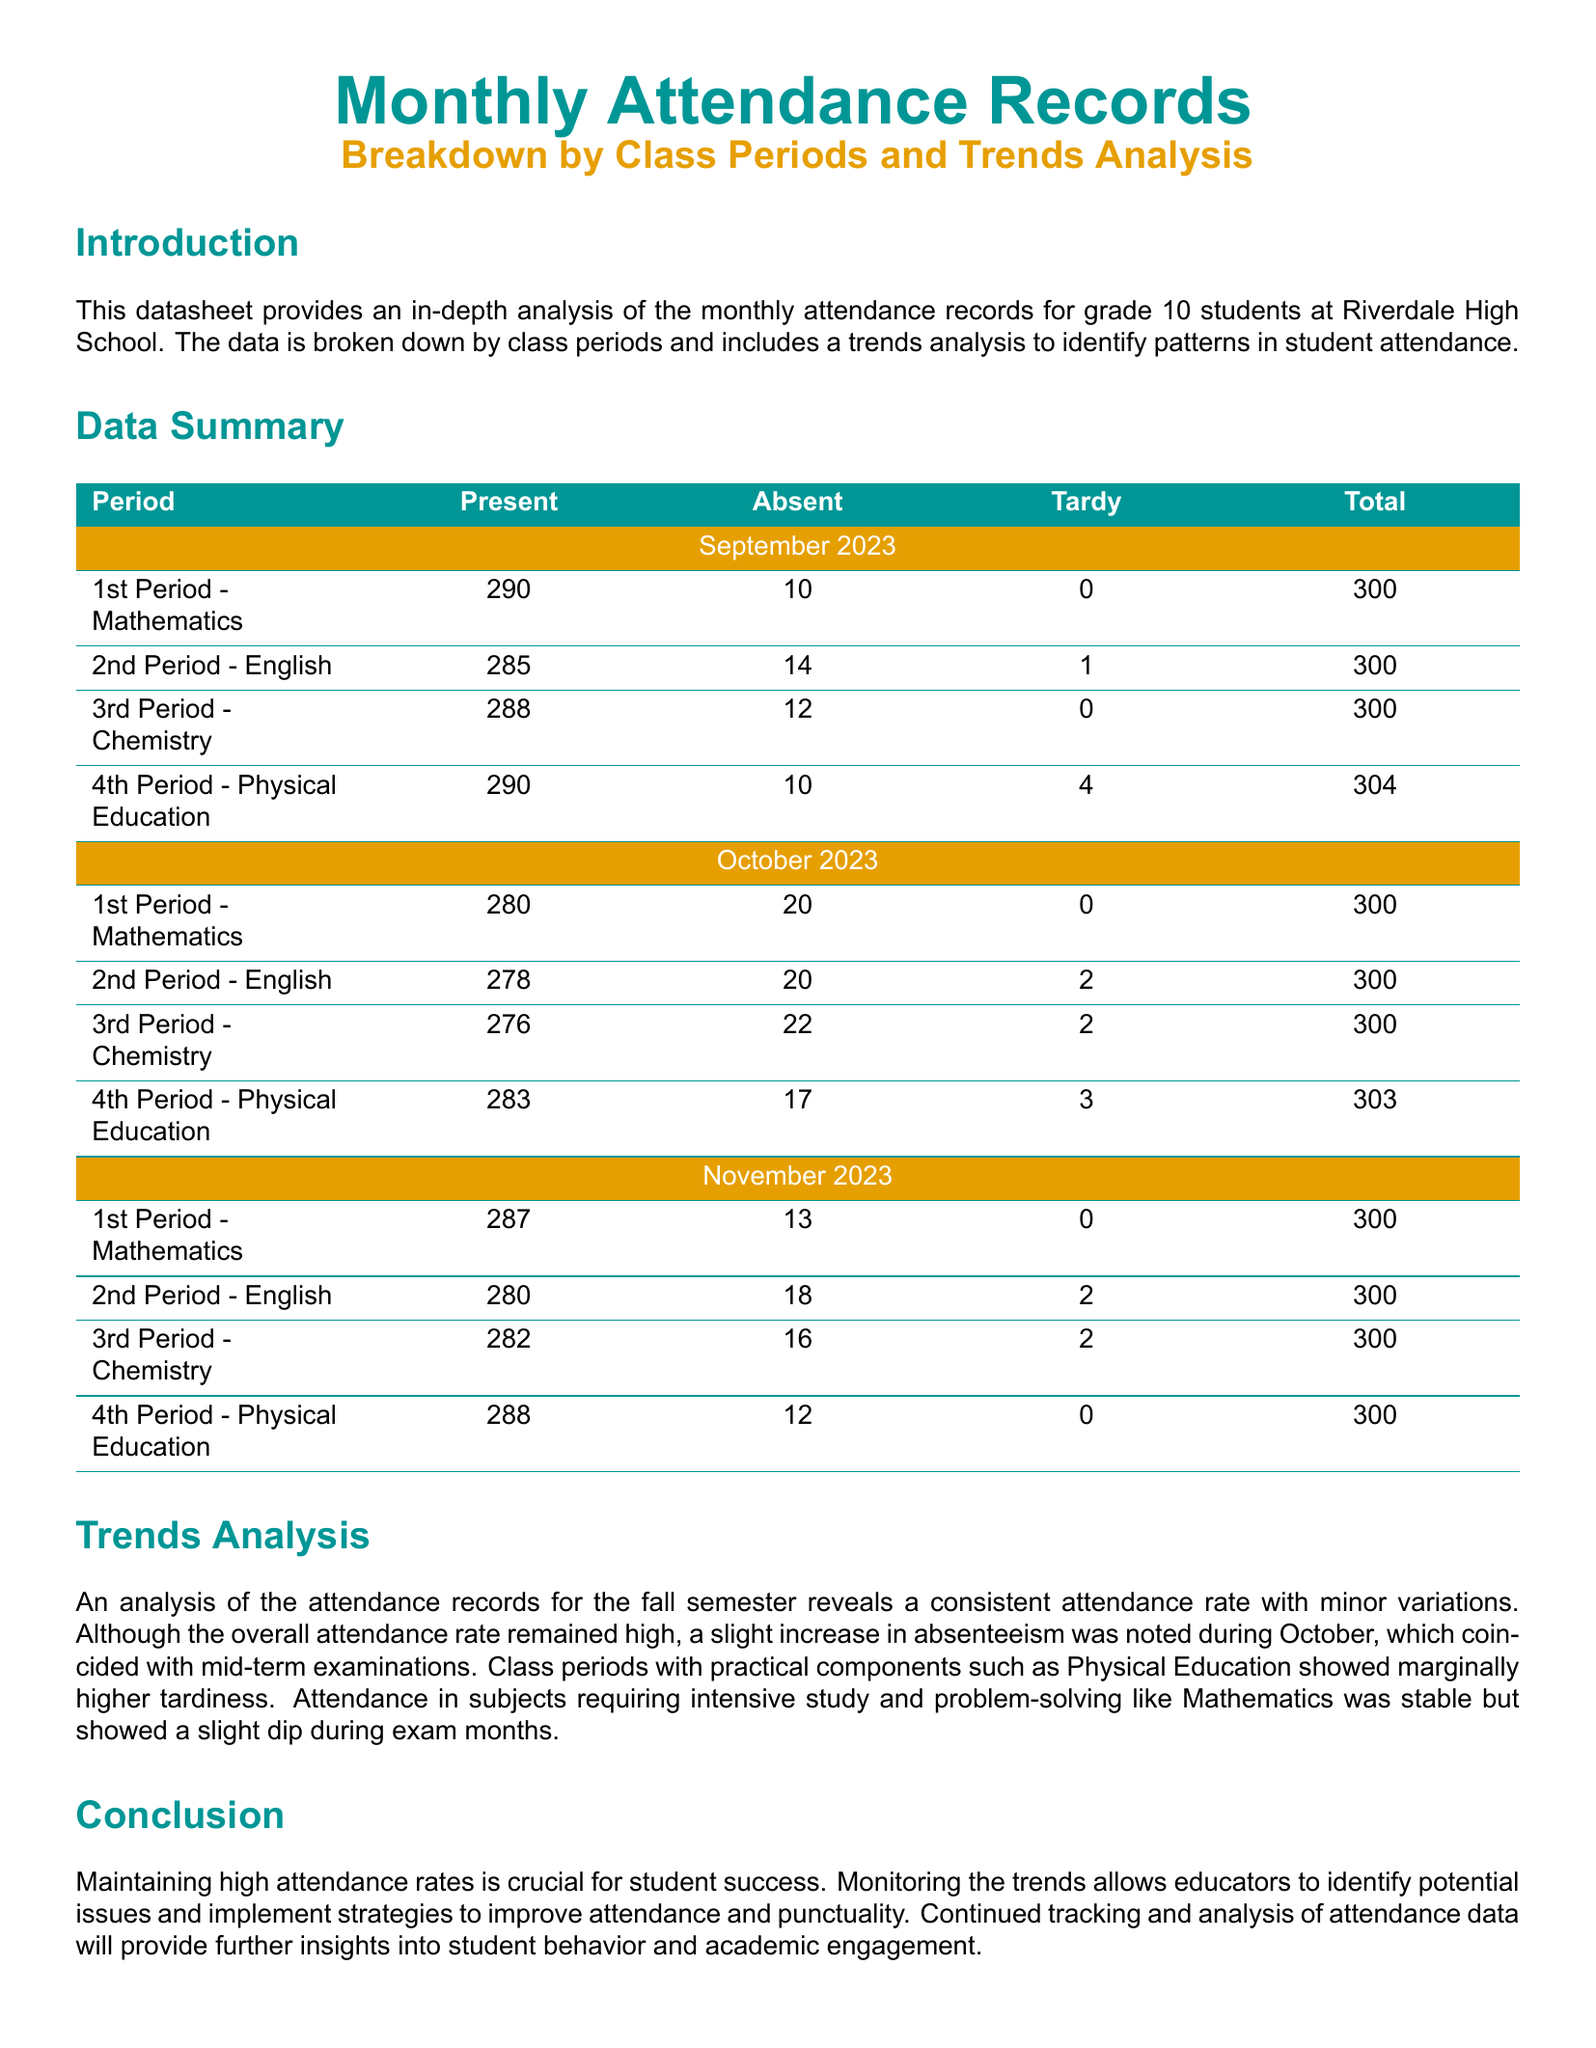What was the total number of students present in the 1st Period - Mathematics for September 2023? The total number of students present in the 1st Period - Mathematics for September 2023 is retrieved from the attendance records.
Answer: 290 What was the number of students tardy in the 4th Period - Physical Education for October 2023? The number of students tardy in the 4th Period - Physical Education for October 2023 can be found in the detailed breakdown of attendance.
Answer: 3 Which month showed a slight increase in absenteeism? The analysis section discusses trends in attendance, revealing that October experienced a slight increase in absenteeism.
Answer: October How many students were absent in the 2nd Period - English for November 2023? The number of students absent in the 2nd Period - English for November 2023 is specifically provided in the data summary of the document.
Answer: 18 What period had the highest number of tardy students in November 2023? By reviewing the tardy figures for each period in November 2023, one can determine which period had the highest number.
Answer: 4th Period - Physical Education What is the focus of this datasheet? The introduction states the focus of the datasheet.
Answer: Monthly Attendance Records What trend was noted regarding attendance during exam months? The trends analysis describes patterns in student attendance during exam months, indicating a stable attendance rate.
Answer: Slight dip What is the total for the 3rd Period - Chemistry in October 2023? The attendance data provides the total number of students for the 3rd Period - Chemistry in October 2023.
Answer: 300 What color is used for section titles in the datasheet? The title formatting section specifies the color used for section titles.
Answer: Matlab teal 